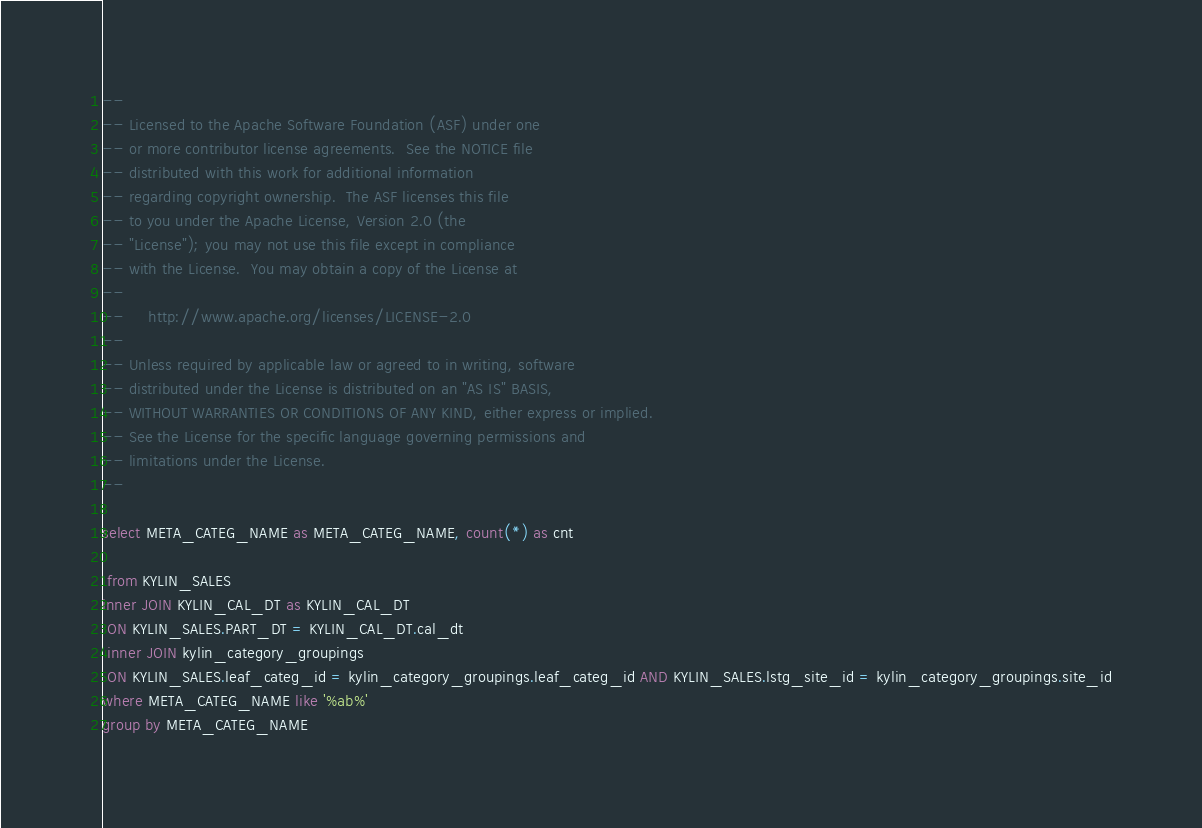Convert code to text. <code><loc_0><loc_0><loc_500><loc_500><_SQL_>--
-- Licensed to the Apache Software Foundation (ASF) under one
-- or more contributor license agreements.  See the NOTICE file
-- distributed with this work for additional information
-- regarding copyright ownership.  The ASF licenses this file
-- to you under the Apache License, Version 2.0 (the
-- "License"); you may not use this file except in compliance
-- with the License.  You may obtain a copy of the License at
--
--     http://www.apache.org/licenses/LICENSE-2.0
--
-- Unless required by applicable law or agreed to in writing, software
-- distributed under the License is distributed on an "AS IS" BASIS,
-- WITHOUT WARRANTIES OR CONDITIONS OF ANY KIND, either express or implied.
-- See the License for the specific language governing permissions and
-- limitations under the License.
--

select META_CATEG_NAME as META_CATEG_NAME, count(*) as cnt 
 
 from KYLIN_SALES
inner JOIN KYLIN_CAL_DT as KYLIN_CAL_DT
 ON KYLIN_SALES.PART_DT = KYLIN_CAL_DT.cal_dt
 inner JOIN kylin_category_groupings
 ON KYLIN_SALES.leaf_categ_id = kylin_category_groupings.leaf_categ_id AND KYLIN_SALES.lstg_site_id = kylin_category_groupings.site_id
where META_CATEG_NAME like '%ab%'
group by META_CATEG_NAME</code> 